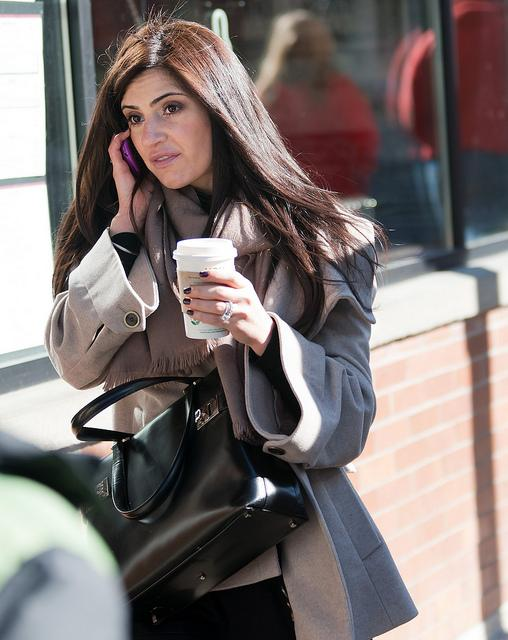What pick me up is found in this woman's cup? Please explain your reasoning. caffeine. The cup is indicative of coffee, which has a natural stimulant. 